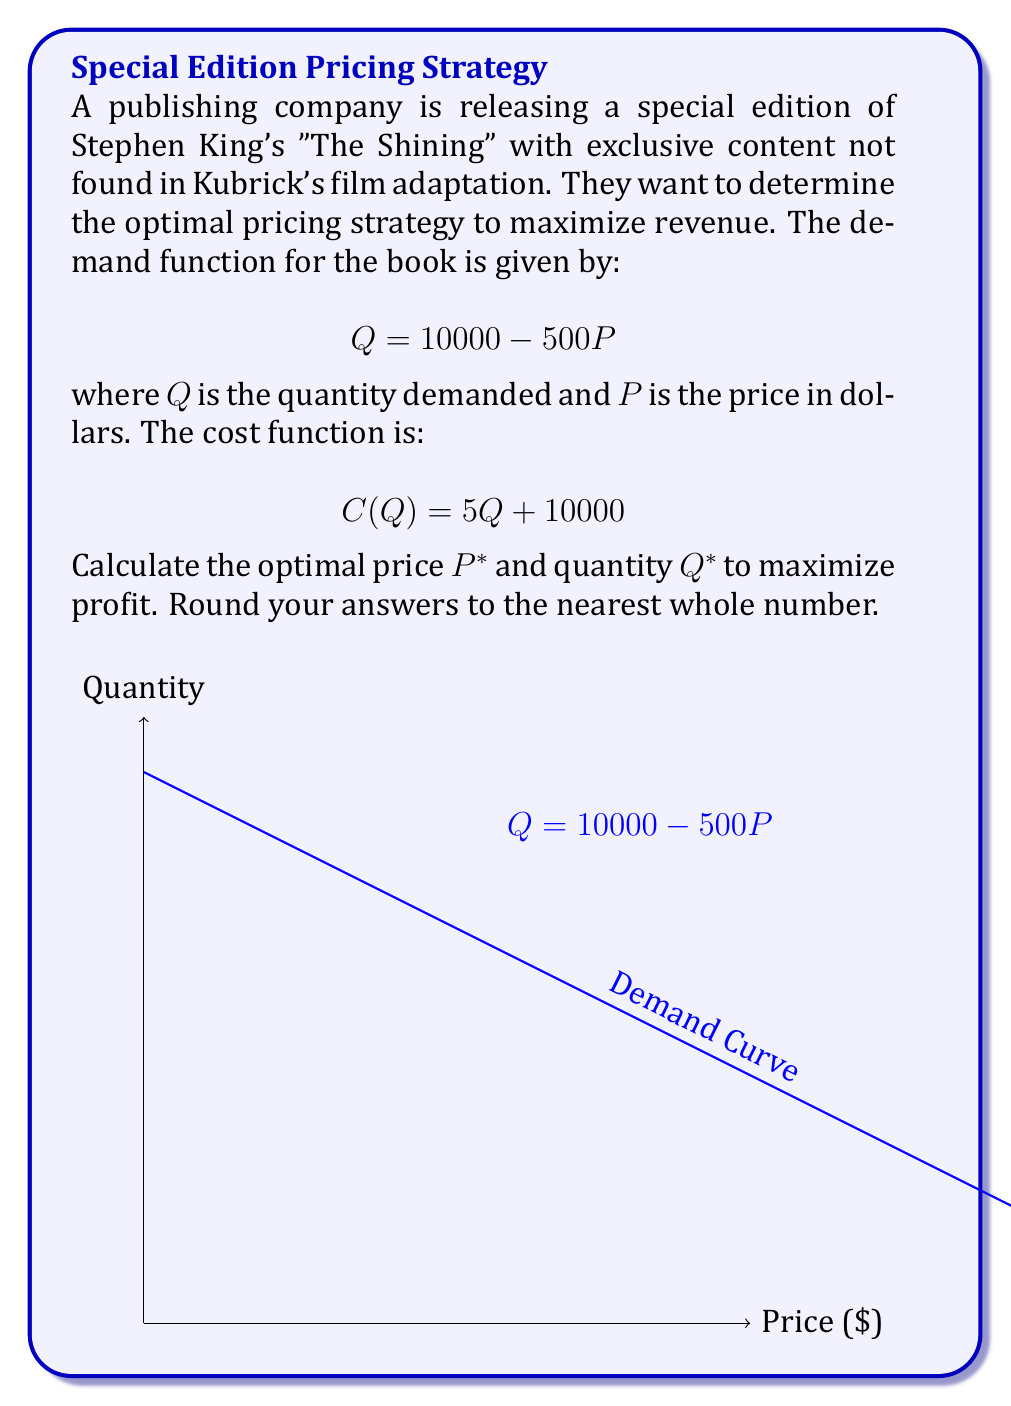Solve this math problem. 1) The profit function $\Pi(Q)$ is given by revenue minus cost:
   $$\Pi(Q) = PQ - C(Q)$$

2) Express P in terms of Q using the demand function:
   $$P = 20 - \frac{Q}{500}$$

3) Substitute this into the profit function:
   $$\Pi(Q) = (20 - \frac{Q}{500})Q - (5Q + 10000)$$
   $$\Pi(Q) = 20Q - \frac{Q^2}{500} - 5Q - 10000$$
   $$\Pi(Q) = 15Q - \frac{Q^2}{500} - 10000$$

4) To find the maximum profit, differentiate $\Pi(Q)$ with respect to Q and set it to zero:
   $$\frac{d\Pi}{dQ} = 15 - \frac{2Q}{500} = 0$$

5) Solve for Q:
   $$\frac{2Q}{500} = 15$$
   $$Q^* = 3750$$

6) Find $P^*$ by substituting $Q^*$ into the demand function:
   $$P^* = 20 - \frac{3750}{500} = 12.5$$

7) Round to the nearest whole numbers:
   $Q^* = 3750$
   $P^* = 13$
Answer: $P^* = 13$, $Q^* = 3750$ 